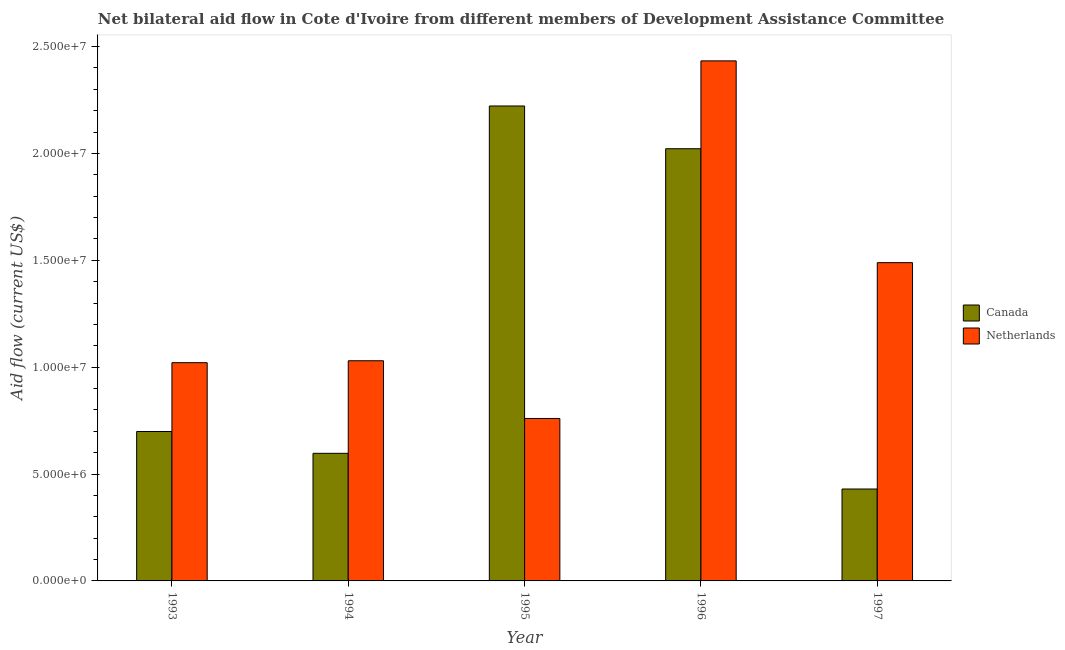How many different coloured bars are there?
Your answer should be compact. 2. How many groups of bars are there?
Make the answer very short. 5. Are the number of bars on each tick of the X-axis equal?
Make the answer very short. Yes. How many bars are there on the 5th tick from the left?
Provide a short and direct response. 2. How many bars are there on the 2nd tick from the right?
Give a very brief answer. 2. In how many cases, is the number of bars for a given year not equal to the number of legend labels?
Your answer should be compact. 0. What is the amount of aid given by canada in 1996?
Keep it short and to the point. 2.02e+07. Across all years, what is the maximum amount of aid given by netherlands?
Provide a short and direct response. 2.43e+07. Across all years, what is the minimum amount of aid given by netherlands?
Your response must be concise. 7.60e+06. In which year was the amount of aid given by canada minimum?
Give a very brief answer. 1997. What is the total amount of aid given by netherlands in the graph?
Give a very brief answer. 6.73e+07. What is the difference between the amount of aid given by canada in 1993 and that in 1994?
Give a very brief answer. 1.02e+06. What is the difference between the amount of aid given by netherlands in 1994 and the amount of aid given by canada in 1993?
Provide a short and direct response. 9.00e+04. What is the average amount of aid given by canada per year?
Offer a terse response. 1.19e+07. In the year 1997, what is the difference between the amount of aid given by netherlands and amount of aid given by canada?
Offer a very short reply. 0. In how many years, is the amount of aid given by netherlands greater than 14000000 US$?
Offer a very short reply. 2. What is the ratio of the amount of aid given by canada in 1993 to that in 1994?
Give a very brief answer. 1.17. Is the difference between the amount of aid given by netherlands in 1993 and 1995 greater than the difference between the amount of aid given by canada in 1993 and 1995?
Your answer should be very brief. No. What is the difference between the highest and the second highest amount of aid given by canada?
Provide a short and direct response. 2.00e+06. What is the difference between the highest and the lowest amount of aid given by canada?
Offer a terse response. 1.79e+07. Are all the bars in the graph horizontal?
Offer a very short reply. No. What is the title of the graph?
Provide a short and direct response. Net bilateral aid flow in Cote d'Ivoire from different members of Development Assistance Committee. What is the label or title of the Y-axis?
Provide a short and direct response. Aid flow (current US$). What is the Aid flow (current US$) in Canada in 1993?
Give a very brief answer. 6.99e+06. What is the Aid flow (current US$) in Netherlands in 1993?
Your answer should be compact. 1.02e+07. What is the Aid flow (current US$) in Canada in 1994?
Keep it short and to the point. 5.97e+06. What is the Aid flow (current US$) of Netherlands in 1994?
Your answer should be compact. 1.03e+07. What is the Aid flow (current US$) of Canada in 1995?
Provide a short and direct response. 2.22e+07. What is the Aid flow (current US$) of Netherlands in 1995?
Offer a terse response. 7.60e+06. What is the Aid flow (current US$) in Canada in 1996?
Make the answer very short. 2.02e+07. What is the Aid flow (current US$) in Netherlands in 1996?
Your answer should be compact. 2.43e+07. What is the Aid flow (current US$) of Canada in 1997?
Your response must be concise. 4.30e+06. What is the Aid flow (current US$) of Netherlands in 1997?
Offer a very short reply. 1.49e+07. Across all years, what is the maximum Aid flow (current US$) in Canada?
Provide a short and direct response. 2.22e+07. Across all years, what is the maximum Aid flow (current US$) in Netherlands?
Keep it short and to the point. 2.43e+07. Across all years, what is the minimum Aid flow (current US$) of Canada?
Make the answer very short. 4.30e+06. Across all years, what is the minimum Aid flow (current US$) in Netherlands?
Ensure brevity in your answer.  7.60e+06. What is the total Aid flow (current US$) in Canada in the graph?
Make the answer very short. 5.97e+07. What is the total Aid flow (current US$) of Netherlands in the graph?
Provide a short and direct response. 6.73e+07. What is the difference between the Aid flow (current US$) of Canada in 1993 and that in 1994?
Provide a short and direct response. 1.02e+06. What is the difference between the Aid flow (current US$) in Canada in 1993 and that in 1995?
Your response must be concise. -1.52e+07. What is the difference between the Aid flow (current US$) of Netherlands in 1993 and that in 1995?
Your response must be concise. 2.61e+06. What is the difference between the Aid flow (current US$) in Canada in 1993 and that in 1996?
Keep it short and to the point. -1.32e+07. What is the difference between the Aid flow (current US$) of Netherlands in 1993 and that in 1996?
Provide a short and direct response. -1.41e+07. What is the difference between the Aid flow (current US$) in Canada in 1993 and that in 1997?
Ensure brevity in your answer.  2.69e+06. What is the difference between the Aid flow (current US$) of Netherlands in 1993 and that in 1997?
Provide a succinct answer. -4.68e+06. What is the difference between the Aid flow (current US$) of Canada in 1994 and that in 1995?
Your response must be concise. -1.62e+07. What is the difference between the Aid flow (current US$) of Netherlands in 1994 and that in 1995?
Provide a short and direct response. 2.70e+06. What is the difference between the Aid flow (current US$) of Canada in 1994 and that in 1996?
Your answer should be compact. -1.42e+07. What is the difference between the Aid flow (current US$) of Netherlands in 1994 and that in 1996?
Your answer should be very brief. -1.40e+07. What is the difference between the Aid flow (current US$) in Canada in 1994 and that in 1997?
Your response must be concise. 1.67e+06. What is the difference between the Aid flow (current US$) in Netherlands in 1994 and that in 1997?
Provide a succinct answer. -4.59e+06. What is the difference between the Aid flow (current US$) in Canada in 1995 and that in 1996?
Keep it short and to the point. 2.00e+06. What is the difference between the Aid flow (current US$) of Netherlands in 1995 and that in 1996?
Ensure brevity in your answer.  -1.67e+07. What is the difference between the Aid flow (current US$) in Canada in 1995 and that in 1997?
Your response must be concise. 1.79e+07. What is the difference between the Aid flow (current US$) in Netherlands in 1995 and that in 1997?
Offer a very short reply. -7.29e+06. What is the difference between the Aid flow (current US$) of Canada in 1996 and that in 1997?
Provide a short and direct response. 1.59e+07. What is the difference between the Aid flow (current US$) in Netherlands in 1996 and that in 1997?
Make the answer very short. 9.44e+06. What is the difference between the Aid flow (current US$) in Canada in 1993 and the Aid flow (current US$) in Netherlands in 1994?
Your answer should be very brief. -3.31e+06. What is the difference between the Aid flow (current US$) in Canada in 1993 and the Aid flow (current US$) in Netherlands in 1995?
Ensure brevity in your answer.  -6.10e+05. What is the difference between the Aid flow (current US$) in Canada in 1993 and the Aid flow (current US$) in Netherlands in 1996?
Offer a terse response. -1.73e+07. What is the difference between the Aid flow (current US$) in Canada in 1993 and the Aid flow (current US$) in Netherlands in 1997?
Your answer should be very brief. -7.90e+06. What is the difference between the Aid flow (current US$) in Canada in 1994 and the Aid flow (current US$) in Netherlands in 1995?
Keep it short and to the point. -1.63e+06. What is the difference between the Aid flow (current US$) of Canada in 1994 and the Aid flow (current US$) of Netherlands in 1996?
Ensure brevity in your answer.  -1.84e+07. What is the difference between the Aid flow (current US$) of Canada in 1994 and the Aid flow (current US$) of Netherlands in 1997?
Your response must be concise. -8.92e+06. What is the difference between the Aid flow (current US$) of Canada in 1995 and the Aid flow (current US$) of Netherlands in 1996?
Offer a very short reply. -2.11e+06. What is the difference between the Aid flow (current US$) in Canada in 1995 and the Aid flow (current US$) in Netherlands in 1997?
Your response must be concise. 7.33e+06. What is the difference between the Aid flow (current US$) in Canada in 1996 and the Aid flow (current US$) in Netherlands in 1997?
Offer a very short reply. 5.33e+06. What is the average Aid flow (current US$) in Canada per year?
Offer a terse response. 1.19e+07. What is the average Aid flow (current US$) in Netherlands per year?
Give a very brief answer. 1.35e+07. In the year 1993, what is the difference between the Aid flow (current US$) in Canada and Aid flow (current US$) in Netherlands?
Give a very brief answer. -3.22e+06. In the year 1994, what is the difference between the Aid flow (current US$) in Canada and Aid flow (current US$) in Netherlands?
Provide a short and direct response. -4.33e+06. In the year 1995, what is the difference between the Aid flow (current US$) of Canada and Aid flow (current US$) of Netherlands?
Ensure brevity in your answer.  1.46e+07. In the year 1996, what is the difference between the Aid flow (current US$) of Canada and Aid flow (current US$) of Netherlands?
Provide a succinct answer. -4.11e+06. In the year 1997, what is the difference between the Aid flow (current US$) of Canada and Aid flow (current US$) of Netherlands?
Provide a short and direct response. -1.06e+07. What is the ratio of the Aid flow (current US$) of Canada in 1993 to that in 1994?
Provide a succinct answer. 1.17. What is the ratio of the Aid flow (current US$) in Netherlands in 1993 to that in 1994?
Ensure brevity in your answer.  0.99. What is the ratio of the Aid flow (current US$) in Canada in 1993 to that in 1995?
Provide a short and direct response. 0.31. What is the ratio of the Aid flow (current US$) in Netherlands in 1993 to that in 1995?
Make the answer very short. 1.34. What is the ratio of the Aid flow (current US$) in Canada in 1993 to that in 1996?
Offer a terse response. 0.35. What is the ratio of the Aid flow (current US$) of Netherlands in 1993 to that in 1996?
Offer a terse response. 0.42. What is the ratio of the Aid flow (current US$) of Canada in 1993 to that in 1997?
Your answer should be compact. 1.63. What is the ratio of the Aid flow (current US$) of Netherlands in 1993 to that in 1997?
Ensure brevity in your answer.  0.69. What is the ratio of the Aid flow (current US$) in Canada in 1994 to that in 1995?
Your response must be concise. 0.27. What is the ratio of the Aid flow (current US$) of Netherlands in 1994 to that in 1995?
Your answer should be compact. 1.36. What is the ratio of the Aid flow (current US$) in Canada in 1994 to that in 1996?
Offer a very short reply. 0.3. What is the ratio of the Aid flow (current US$) in Netherlands in 1994 to that in 1996?
Provide a short and direct response. 0.42. What is the ratio of the Aid flow (current US$) in Canada in 1994 to that in 1997?
Your answer should be very brief. 1.39. What is the ratio of the Aid flow (current US$) in Netherlands in 1994 to that in 1997?
Your answer should be very brief. 0.69. What is the ratio of the Aid flow (current US$) of Canada in 1995 to that in 1996?
Your answer should be very brief. 1.1. What is the ratio of the Aid flow (current US$) of Netherlands in 1995 to that in 1996?
Your response must be concise. 0.31. What is the ratio of the Aid flow (current US$) in Canada in 1995 to that in 1997?
Provide a succinct answer. 5.17. What is the ratio of the Aid flow (current US$) of Netherlands in 1995 to that in 1997?
Provide a short and direct response. 0.51. What is the ratio of the Aid flow (current US$) of Canada in 1996 to that in 1997?
Provide a short and direct response. 4.7. What is the ratio of the Aid flow (current US$) in Netherlands in 1996 to that in 1997?
Ensure brevity in your answer.  1.63. What is the difference between the highest and the second highest Aid flow (current US$) in Canada?
Your answer should be compact. 2.00e+06. What is the difference between the highest and the second highest Aid flow (current US$) in Netherlands?
Provide a succinct answer. 9.44e+06. What is the difference between the highest and the lowest Aid flow (current US$) in Canada?
Ensure brevity in your answer.  1.79e+07. What is the difference between the highest and the lowest Aid flow (current US$) in Netherlands?
Provide a succinct answer. 1.67e+07. 